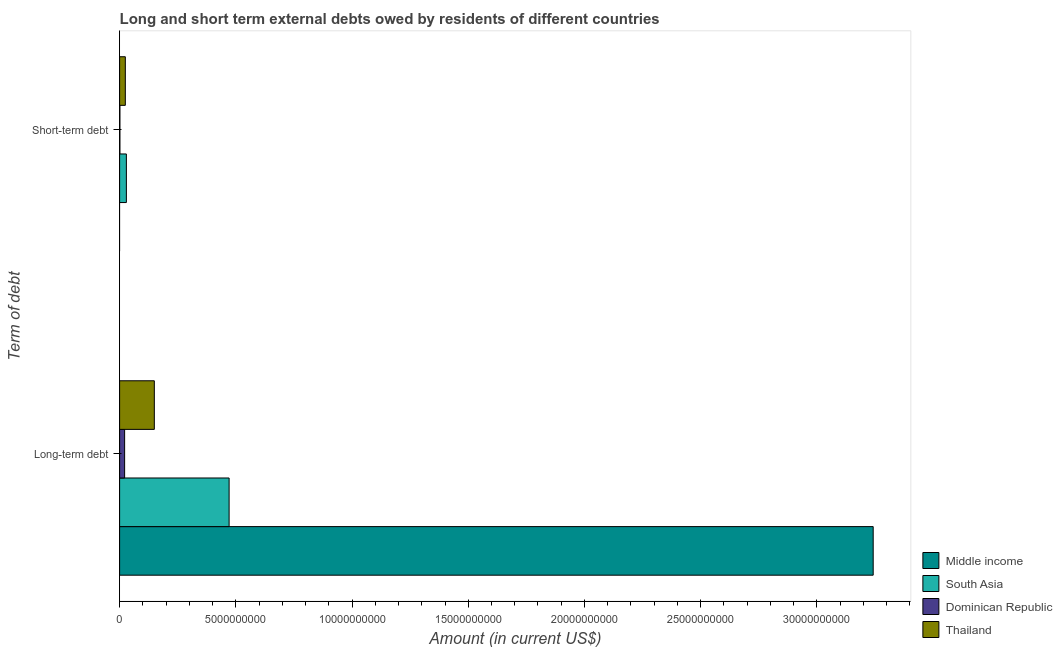How many different coloured bars are there?
Ensure brevity in your answer.  4. Are the number of bars per tick equal to the number of legend labels?
Provide a succinct answer. No. How many bars are there on the 2nd tick from the top?
Your response must be concise. 4. How many bars are there on the 2nd tick from the bottom?
Make the answer very short. 3. What is the label of the 2nd group of bars from the top?
Make the answer very short. Long-term debt. What is the short-term debts owed by residents in Dominican Republic?
Provide a short and direct response. 1.30e+07. Across all countries, what is the maximum long-term debts owed by residents?
Ensure brevity in your answer.  3.24e+1. Across all countries, what is the minimum short-term debts owed by residents?
Ensure brevity in your answer.  0. What is the total long-term debts owed by residents in the graph?
Provide a short and direct response. 3.88e+1. What is the difference between the short-term debts owed by residents in Dominican Republic and that in Thailand?
Offer a terse response. -2.33e+08. What is the difference between the short-term debts owed by residents in Thailand and the long-term debts owed by residents in Middle income?
Make the answer very short. -3.22e+1. What is the average short-term debts owed by residents per country?
Give a very brief answer. 1.38e+08. What is the difference between the short-term debts owed by residents and long-term debts owed by residents in Thailand?
Offer a very short reply. -1.25e+09. What is the ratio of the long-term debts owed by residents in Thailand to that in Middle income?
Your answer should be compact. 0.05. Is the long-term debts owed by residents in Dominican Republic less than that in South Asia?
Provide a succinct answer. Yes. How many bars are there?
Provide a short and direct response. 7. Are all the bars in the graph horizontal?
Your answer should be compact. Yes. What is the difference between two consecutive major ticks on the X-axis?
Provide a succinct answer. 5.00e+09. Are the values on the major ticks of X-axis written in scientific E-notation?
Make the answer very short. No. How many legend labels are there?
Keep it short and to the point. 4. How are the legend labels stacked?
Offer a very short reply. Vertical. What is the title of the graph?
Ensure brevity in your answer.  Long and short term external debts owed by residents of different countries. What is the label or title of the Y-axis?
Give a very brief answer. Term of debt. What is the Amount (in current US$) of Middle income in Long-term debt?
Offer a terse response. 3.24e+1. What is the Amount (in current US$) of South Asia in Long-term debt?
Your answer should be very brief. 4.71e+09. What is the Amount (in current US$) of Dominican Republic in Long-term debt?
Provide a succinct answer. 2.16e+08. What is the Amount (in current US$) of Thailand in Long-term debt?
Ensure brevity in your answer.  1.49e+09. What is the Amount (in current US$) of Middle income in Short-term debt?
Provide a succinct answer. 0. What is the Amount (in current US$) in South Asia in Short-term debt?
Give a very brief answer. 2.91e+08. What is the Amount (in current US$) in Dominican Republic in Short-term debt?
Offer a very short reply. 1.30e+07. What is the Amount (in current US$) of Thailand in Short-term debt?
Provide a succinct answer. 2.46e+08. Across all Term of debt, what is the maximum Amount (in current US$) of Middle income?
Provide a succinct answer. 3.24e+1. Across all Term of debt, what is the maximum Amount (in current US$) of South Asia?
Give a very brief answer. 4.71e+09. Across all Term of debt, what is the maximum Amount (in current US$) in Dominican Republic?
Your answer should be compact. 2.16e+08. Across all Term of debt, what is the maximum Amount (in current US$) in Thailand?
Provide a succinct answer. 1.49e+09. Across all Term of debt, what is the minimum Amount (in current US$) in South Asia?
Your answer should be very brief. 2.91e+08. Across all Term of debt, what is the minimum Amount (in current US$) in Dominican Republic?
Offer a terse response. 1.30e+07. Across all Term of debt, what is the minimum Amount (in current US$) in Thailand?
Offer a very short reply. 2.46e+08. What is the total Amount (in current US$) of Middle income in the graph?
Ensure brevity in your answer.  3.24e+1. What is the total Amount (in current US$) in South Asia in the graph?
Make the answer very short. 5.00e+09. What is the total Amount (in current US$) in Dominican Republic in the graph?
Keep it short and to the point. 2.29e+08. What is the total Amount (in current US$) of Thailand in the graph?
Ensure brevity in your answer.  1.74e+09. What is the difference between the Amount (in current US$) in South Asia in Long-term debt and that in Short-term debt?
Give a very brief answer. 4.42e+09. What is the difference between the Amount (in current US$) of Dominican Republic in Long-term debt and that in Short-term debt?
Your answer should be compact. 2.03e+08. What is the difference between the Amount (in current US$) of Thailand in Long-term debt and that in Short-term debt?
Make the answer very short. 1.25e+09. What is the difference between the Amount (in current US$) in Middle income in Long-term debt and the Amount (in current US$) in South Asia in Short-term debt?
Give a very brief answer. 3.21e+1. What is the difference between the Amount (in current US$) of Middle income in Long-term debt and the Amount (in current US$) of Dominican Republic in Short-term debt?
Provide a short and direct response. 3.24e+1. What is the difference between the Amount (in current US$) of Middle income in Long-term debt and the Amount (in current US$) of Thailand in Short-term debt?
Your response must be concise. 3.22e+1. What is the difference between the Amount (in current US$) in South Asia in Long-term debt and the Amount (in current US$) in Dominican Republic in Short-term debt?
Ensure brevity in your answer.  4.70e+09. What is the difference between the Amount (in current US$) of South Asia in Long-term debt and the Amount (in current US$) of Thailand in Short-term debt?
Your answer should be compact. 4.47e+09. What is the difference between the Amount (in current US$) in Dominican Republic in Long-term debt and the Amount (in current US$) in Thailand in Short-term debt?
Provide a succinct answer. -3.00e+07. What is the average Amount (in current US$) in Middle income per Term of debt?
Make the answer very short. 1.62e+1. What is the average Amount (in current US$) in South Asia per Term of debt?
Offer a terse response. 2.50e+09. What is the average Amount (in current US$) of Dominican Republic per Term of debt?
Provide a succinct answer. 1.15e+08. What is the average Amount (in current US$) of Thailand per Term of debt?
Your response must be concise. 8.70e+08. What is the difference between the Amount (in current US$) of Middle income and Amount (in current US$) of South Asia in Long-term debt?
Your answer should be very brief. 2.77e+1. What is the difference between the Amount (in current US$) in Middle income and Amount (in current US$) in Dominican Republic in Long-term debt?
Offer a terse response. 3.22e+1. What is the difference between the Amount (in current US$) of Middle income and Amount (in current US$) of Thailand in Long-term debt?
Provide a succinct answer. 3.09e+1. What is the difference between the Amount (in current US$) of South Asia and Amount (in current US$) of Dominican Republic in Long-term debt?
Provide a short and direct response. 4.50e+09. What is the difference between the Amount (in current US$) of South Asia and Amount (in current US$) of Thailand in Long-term debt?
Your answer should be compact. 3.22e+09. What is the difference between the Amount (in current US$) of Dominican Republic and Amount (in current US$) of Thailand in Long-term debt?
Offer a very short reply. -1.28e+09. What is the difference between the Amount (in current US$) in South Asia and Amount (in current US$) in Dominican Republic in Short-term debt?
Ensure brevity in your answer.  2.78e+08. What is the difference between the Amount (in current US$) in South Asia and Amount (in current US$) in Thailand in Short-term debt?
Your answer should be compact. 4.51e+07. What is the difference between the Amount (in current US$) in Dominican Republic and Amount (in current US$) in Thailand in Short-term debt?
Your answer should be very brief. -2.33e+08. What is the ratio of the Amount (in current US$) in South Asia in Long-term debt to that in Short-term debt?
Provide a succinct answer. 16.18. What is the ratio of the Amount (in current US$) of Dominican Republic in Long-term debt to that in Short-term debt?
Give a very brief answer. 16.62. What is the ratio of the Amount (in current US$) of Thailand in Long-term debt to that in Short-term debt?
Offer a terse response. 6.07. What is the difference between the highest and the second highest Amount (in current US$) of South Asia?
Provide a short and direct response. 4.42e+09. What is the difference between the highest and the second highest Amount (in current US$) of Dominican Republic?
Your answer should be compact. 2.03e+08. What is the difference between the highest and the second highest Amount (in current US$) in Thailand?
Offer a terse response. 1.25e+09. What is the difference between the highest and the lowest Amount (in current US$) of Middle income?
Your response must be concise. 3.24e+1. What is the difference between the highest and the lowest Amount (in current US$) of South Asia?
Give a very brief answer. 4.42e+09. What is the difference between the highest and the lowest Amount (in current US$) in Dominican Republic?
Provide a short and direct response. 2.03e+08. What is the difference between the highest and the lowest Amount (in current US$) in Thailand?
Your answer should be compact. 1.25e+09. 